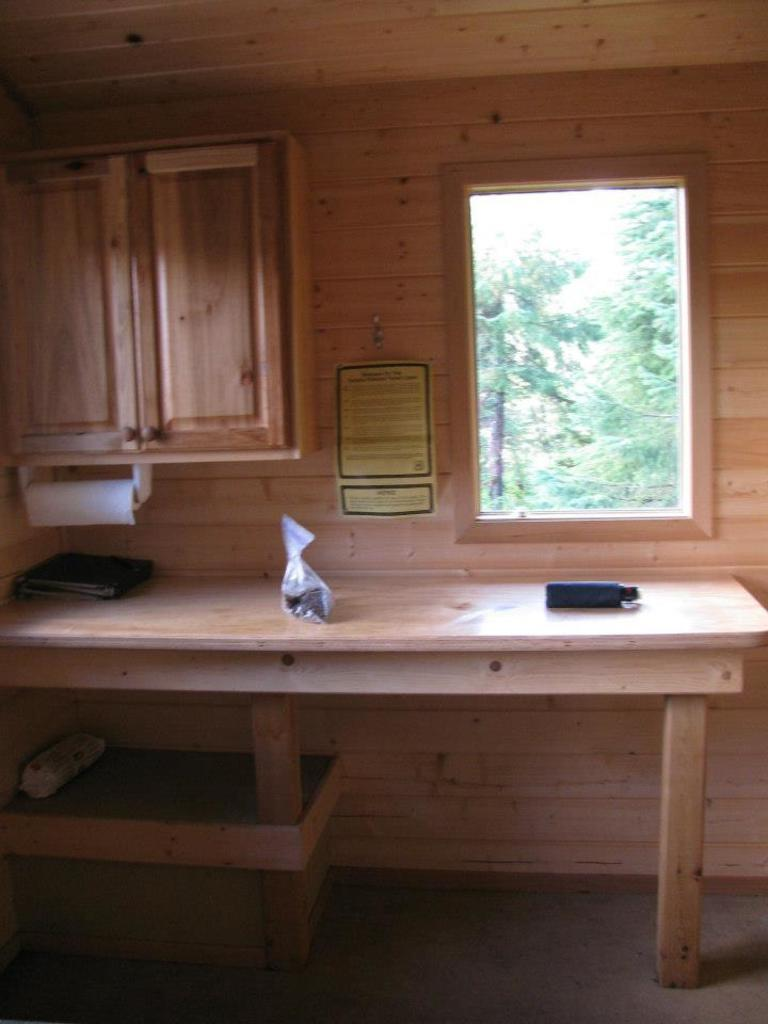What can be seen on the table in the image? There are objects on the table in the image. What is visible in the background through the window? There are trees visible in the background through a window. What else can be seen in the background? There is a wall visible in the background. Can you tell me how many harmonies are being played in the image? There is no reference to music or harmonies in the image, so it is not possible to answer that question. 